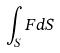<formula> <loc_0><loc_0><loc_500><loc_500>\int _ { S } F d S</formula> 